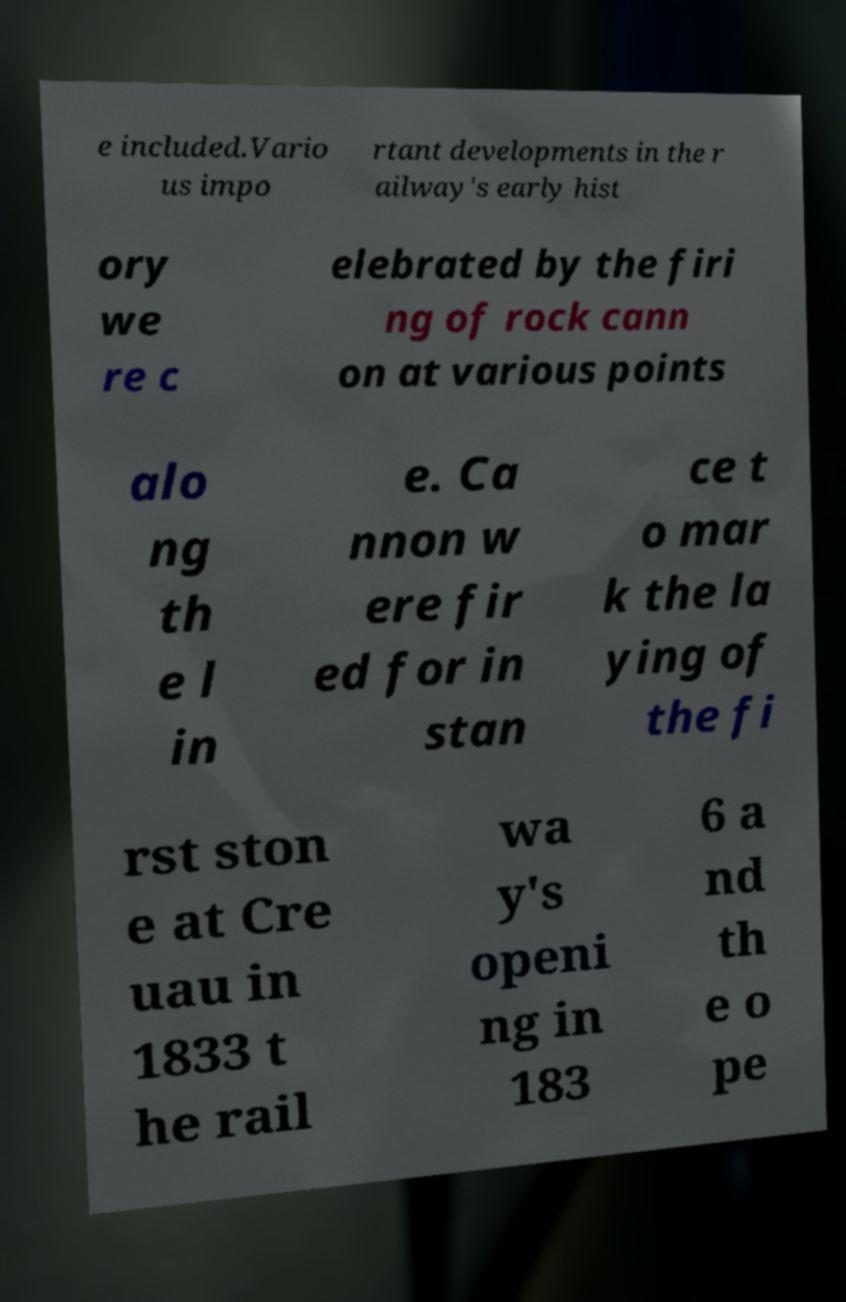For documentation purposes, I need the text within this image transcribed. Could you provide that? e included.Vario us impo rtant developments in the r ailway's early hist ory we re c elebrated by the firi ng of rock cann on at various points alo ng th e l in e. Ca nnon w ere fir ed for in stan ce t o mar k the la ying of the fi rst ston e at Cre uau in 1833 t he rail wa y's openi ng in 183 6 a nd th e o pe 